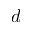Convert formula to latex. <formula><loc_0><loc_0><loc_500><loc_500>d</formula> 